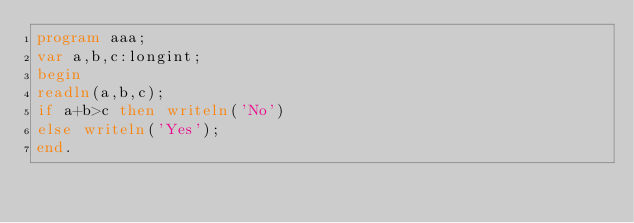Convert code to text. <code><loc_0><loc_0><loc_500><loc_500><_Pascal_>program aaa;
var a,b,c:longint;
begin
readln(a,b,c);
if a+b>c then writeln('No')
else writeln('Yes');
end.</code> 